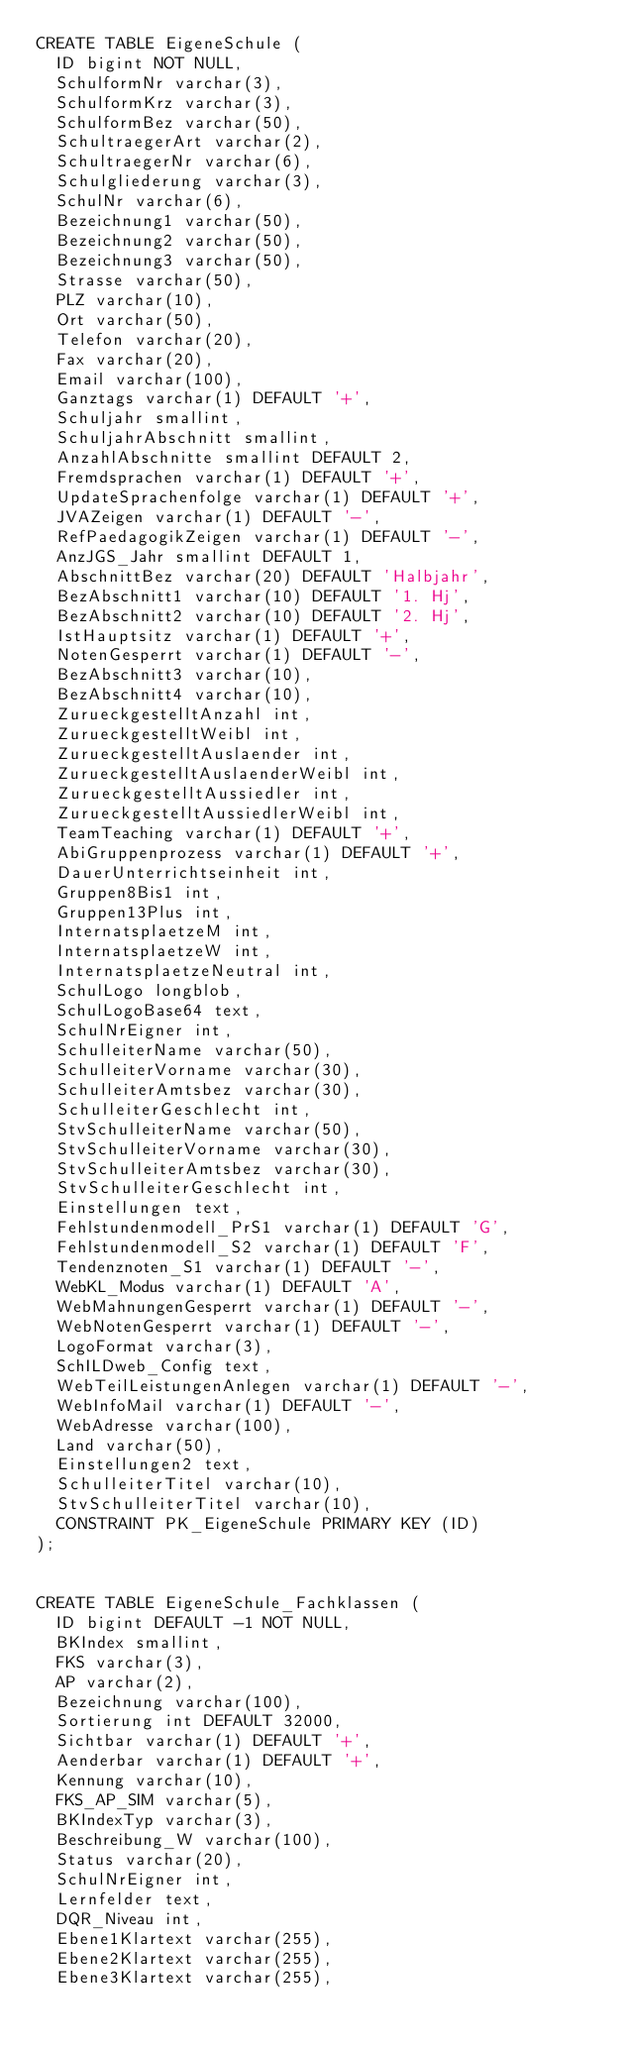<code> <loc_0><loc_0><loc_500><loc_500><_SQL_>CREATE TABLE EigeneSchule (
  ID bigint NOT NULL, 
  SchulformNr varchar(3), 
  SchulformKrz varchar(3), 
  SchulformBez varchar(50), 
  SchultraegerArt varchar(2), 
  SchultraegerNr varchar(6), 
  Schulgliederung varchar(3), 
  SchulNr varchar(6), 
  Bezeichnung1 varchar(50), 
  Bezeichnung2 varchar(50), 
  Bezeichnung3 varchar(50), 
  Strasse varchar(50), 
  PLZ varchar(10), 
  Ort varchar(50), 
  Telefon varchar(20), 
  Fax varchar(20), 
  Email varchar(100), 
  Ganztags varchar(1) DEFAULT '+', 
  Schuljahr smallint, 
  SchuljahrAbschnitt smallint, 
  AnzahlAbschnitte smallint DEFAULT 2, 
  Fremdsprachen varchar(1) DEFAULT '+', 
  UpdateSprachenfolge varchar(1) DEFAULT '+', 
  JVAZeigen varchar(1) DEFAULT '-', 
  RefPaedagogikZeigen varchar(1) DEFAULT '-', 
  AnzJGS_Jahr smallint DEFAULT 1, 
  AbschnittBez varchar(20) DEFAULT 'Halbjahr', 
  BezAbschnitt1 varchar(10) DEFAULT '1. Hj', 
  BezAbschnitt2 varchar(10) DEFAULT '2. Hj', 
  IstHauptsitz varchar(1) DEFAULT '+', 
  NotenGesperrt varchar(1) DEFAULT '-', 
  BezAbschnitt3 varchar(10), 
  BezAbschnitt4 varchar(10), 
  ZurueckgestelltAnzahl int, 
  ZurueckgestelltWeibl int, 
  ZurueckgestelltAuslaender int, 
  ZurueckgestelltAuslaenderWeibl int, 
  ZurueckgestelltAussiedler int, 
  ZurueckgestelltAussiedlerWeibl int, 
  TeamTeaching varchar(1) DEFAULT '+', 
  AbiGruppenprozess varchar(1) DEFAULT '+', 
  DauerUnterrichtseinheit int, 
  Gruppen8Bis1 int, 
  Gruppen13Plus int, 
  InternatsplaetzeM int, 
  InternatsplaetzeW int, 
  InternatsplaetzeNeutral int, 
  SchulLogo longblob, 
  SchulLogoBase64 text, 
  SchulNrEigner int, 
  SchulleiterName varchar(50), 
  SchulleiterVorname varchar(30), 
  SchulleiterAmtsbez varchar(30), 
  SchulleiterGeschlecht int, 
  StvSchulleiterName varchar(50), 
  StvSchulleiterVorname varchar(30), 
  StvSchulleiterAmtsbez varchar(30), 
  StvSchulleiterGeschlecht int, 
  Einstellungen text, 
  Fehlstundenmodell_PrS1 varchar(1) DEFAULT 'G', 
  Fehlstundenmodell_S2 varchar(1) DEFAULT 'F', 
  Tendenznoten_S1 varchar(1) DEFAULT '-', 
  WebKL_Modus varchar(1) DEFAULT 'A', 
  WebMahnungenGesperrt varchar(1) DEFAULT '-', 
  WebNotenGesperrt varchar(1) DEFAULT '-', 
  LogoFormat varchar(3), 
  SchILDweb_Config text, 
  WebTeilLeistungenAnlegen varchar(1) DEFAULT '-', 
  WebInfoMail varchar(1) DEFAULT '-', 
  WebAdresse varchar(100), 
  Land varchar(50), 
  Einstellungen2 text, 
  SchulleiterTitel varchar(10), 
  StvSchulleiterTitel varchar(10),
  CONSTRAINT PK_EigeneSchule PRIMARY KEY (ID)
);


CREATE TABLE EigeneSchule_Fachklassen (
  ID bigint DEFAULT -1 NOT NULL, 
  BKIndex smallint, 
  FKS varchar(3), 
  AP varchar(2), 
  Bezeichnung varchar(100), 
  Sortierung int DEFAULT 32000, 
  Sichtbar varchar(1) DEFAULT '+', 
  Aenderbar varchar(1) DEFAULT '+', 
  Kennung varchar(10), 
  FKS_AP_SIM varchar(5), 
  BKIndexTyp varchar(3), 
  Beschreibung_W varchar(100), 
  Status varchar(20), 
  SchulNrEigner int, 
  Lernfelder text, 
  DQR_Niveau int, 
  Ebene1Klartext varchar(255), 
  Ebene2Klartext varchar(255), 
  Ebene3Klartext varchar(255),</code> 